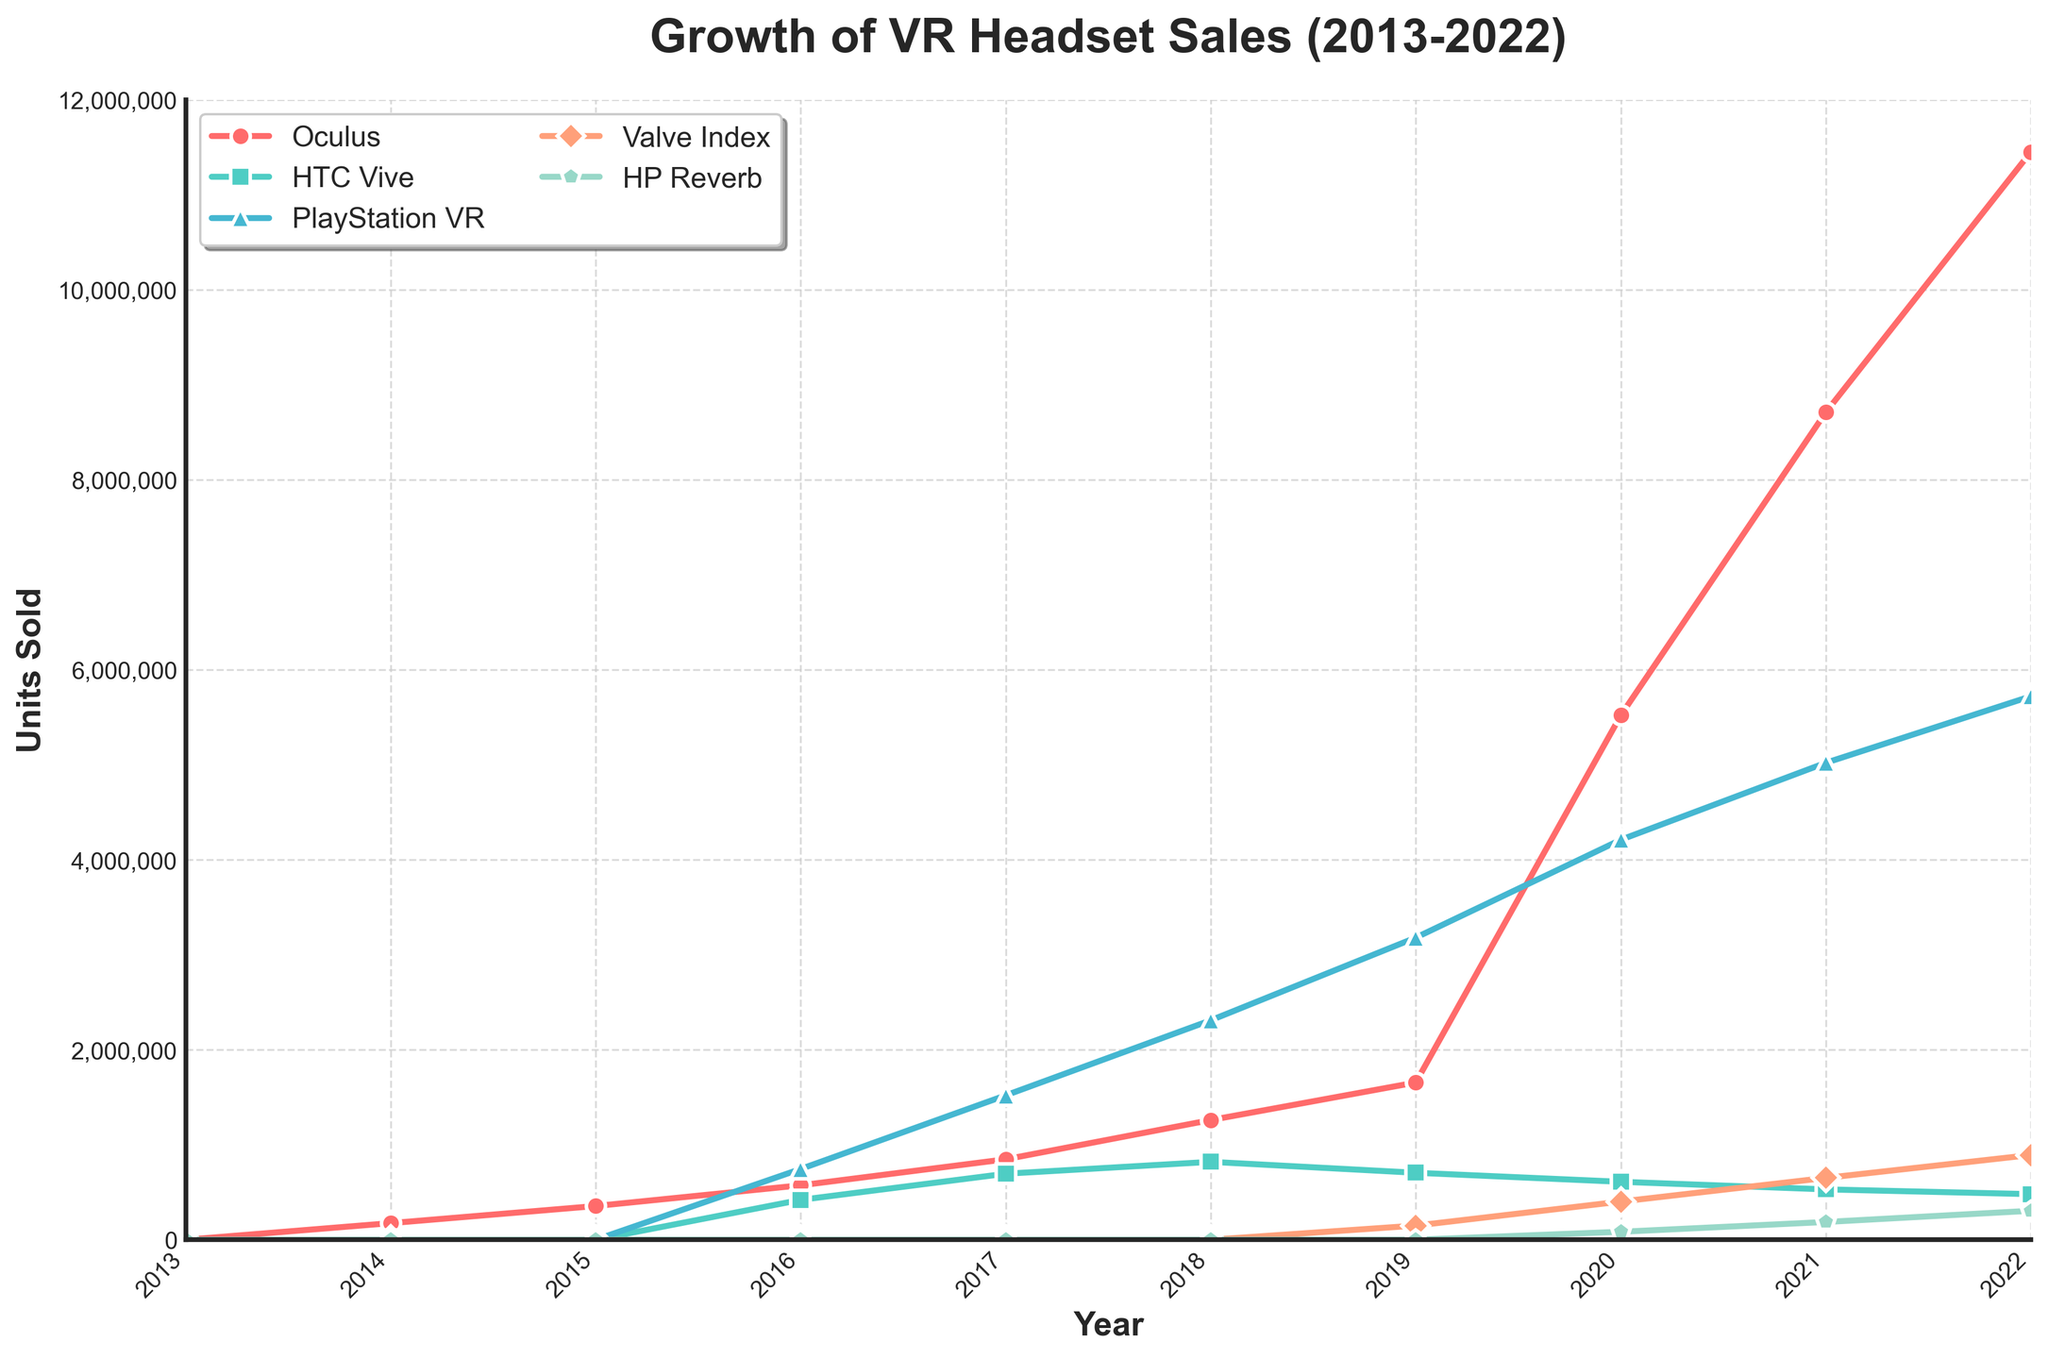What's the total number of units sold by Oculus from 2013 to 2022? Sum the yearly sales of Oculus from 2013 to 2022: 0 + 175,000 + 355,000 + 573,000 + 847,000 + 1,260,000 + 1,655,000 + 5,520,000 + 8,710,000 + 11,450,000
Answer: 30,545,000 Which brand had the highest number of units sold in 2022? Look at the graph for the year 2022 and identify the highest point across the brands, which corresponds to the brand with the highest sales
Answer: PlayStation VR By how much did the sales of PlayStation VR increase from 2016 to 2018? Find the values for 2016 and 2018 and subtract: 2,310,000 (2018) - 745,000 (2016)
Answer: 1,565,000 Which two brands had the closest sales numbers in 2014, and what were those numbers? Compare the sales numbers for 2014 for each brand and find the two brands with the smallest difference. Only Oculus had sales in 2014, so the closest are both Oculus with the same numbers
Answer: Oculus with 175,000 units In which year did Valve Index first appear in the market, and how many units were sold that year? Identify the first non-zero value for Valve Index, which appears in the year 2019
Answer: 2019, 149,000 units What is the average annual sales of HTC Vive from 2016 to 2022? Calculate the average by summing the sales from 2016 to 2022 and dividing by the number of years: (420,000 + 695,000 + 820,000 + 705,000 + 610,000 + 530,000 + 480,000) / 7
Answer: 608,571 units Between which consecutive years did Oculus experience the largest increase in sales? Calculate the differences between consecutive years and identify the largest one. The differences are: 
(355,000 - 175,000) = 180,000, 
(573,000 - 355,000) = 218,000, 
(847,000 - 573,000) = 274,000, 
(1,260,000 - 847,000) = 413,000, 
(1,655,000 - 1,260,000) = 395,000, 
(5,520,000 - 1,655,000) = 3,865,000, 
(8,710,000 - 5,520,000) = 3,190,000,
(11,450,000 - 8,710,000) = 2,740,000;
The largest increase is between 2019 and 2020
Answer: 2019 and 2020 By what factor did HP Reverb sales change from 2019 to 2020? Divide the 2020 sales by the 2019 sales: 84,000 / 0. Given that there were no sales before 2020, the factor can be considered infinite
Answer: Infinite 